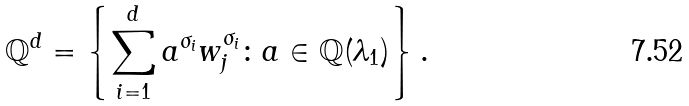<formula> <loc_0><loc_0><loc_500><loc_500>\mathbb { Q } ^ { d } = \left \{ \sum _ { i = 1 } ^ { d } a ^ { \sigma _ { i } } w _ { j } ^ { \sigma _ { i } } \colon a \in \mathbb { Q } ( \lambda _ { 1 } ) \right \} .</formula> 